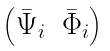Convert formula to latex. <formula><loc_0><loc_0><loc_500><loc_500>\begin{pmatrix} \bar { \Psi } _ { i } & \bar { \Phi } _ { i } \end{pmatrix}</formula> 